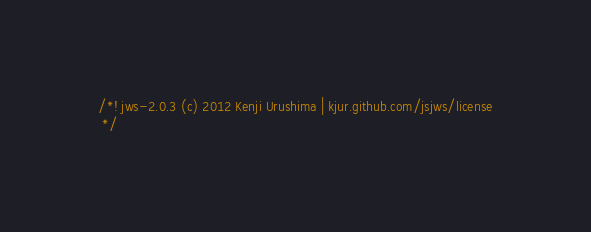<code> <loc_0><loc_0><loc_500><loc_500><_JavaScript_>/*! jws-2.0.3 (c) 2012 Kenji Urushima | kjur.github.com/jsjws/license
 */</code> 